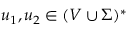<formula> <loc_0><loc_0><loc_500><loc_500>u _ { 1 } , u _ { 2 } \in ( V \cup \Sigma ) ^ { * }</formula> 